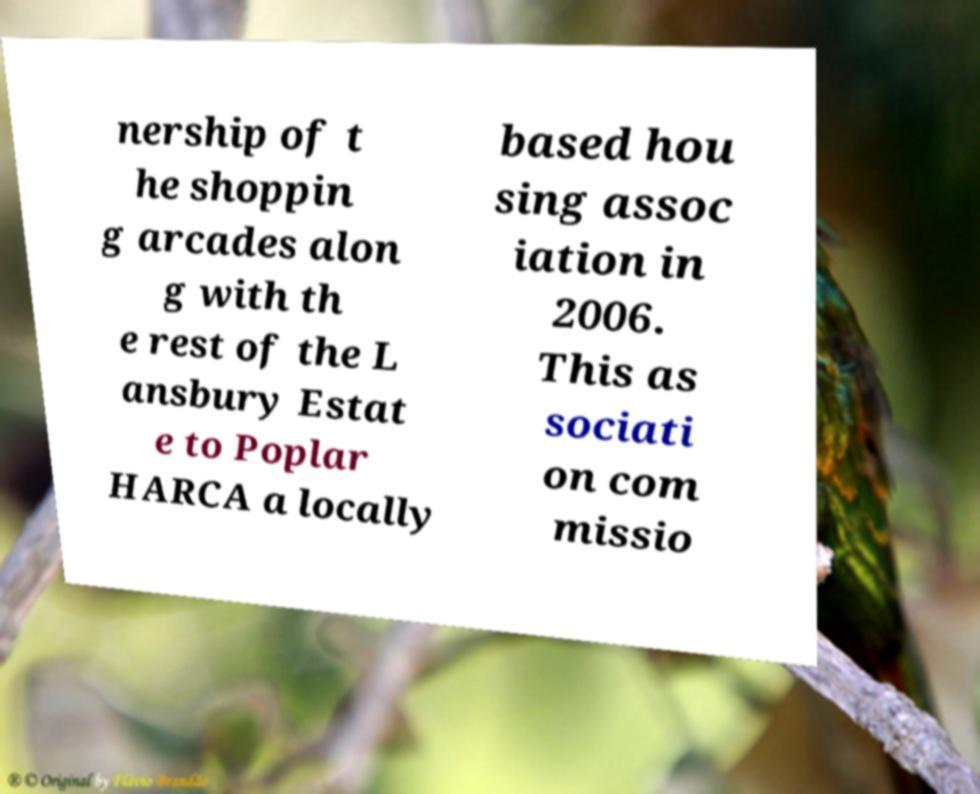There's text embedded in this image that I need extracted. Can you transcribe it verbatim? nership of t he shoppin g arcades alon g with th e rest of the L ansbury Estat e to Poplar HARCA a locally based hou sing assoc iation in 2006. This as sociati on com missio 